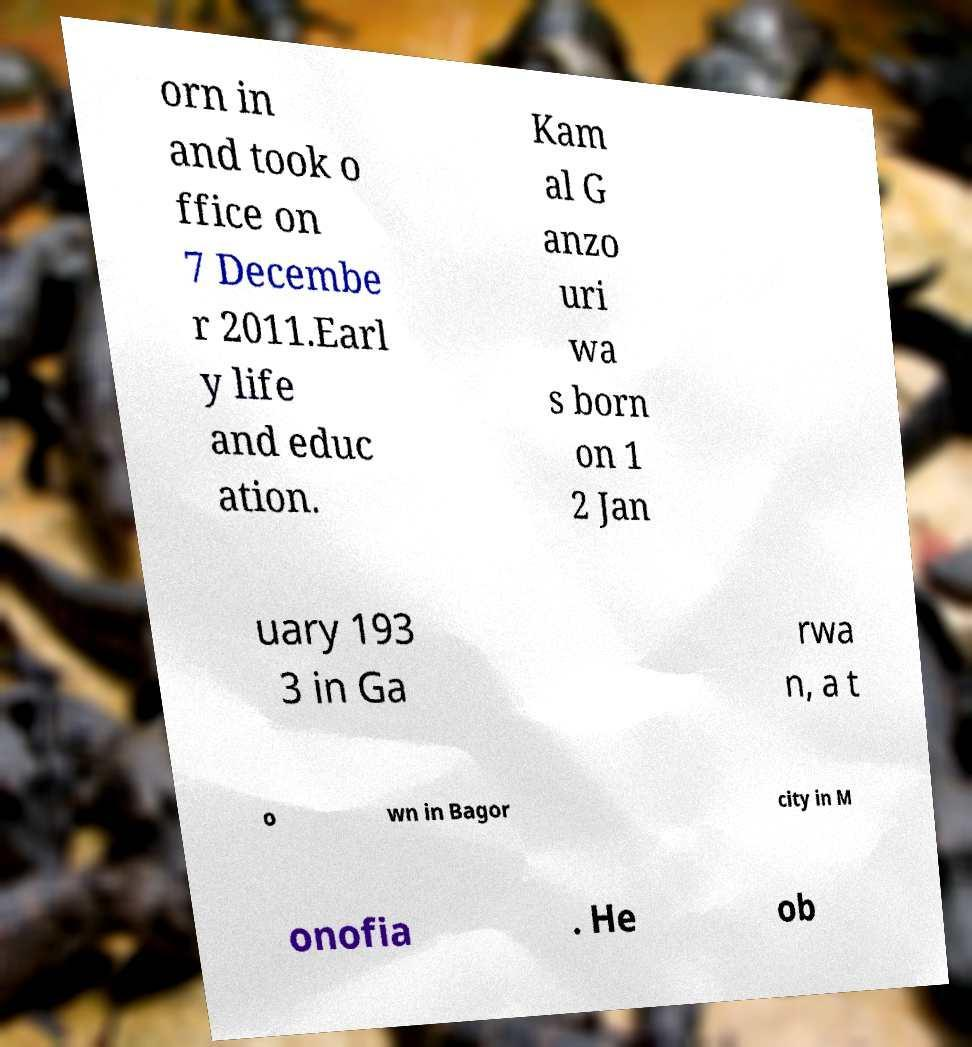For documentation purposes, I need the text within this image transcribed. Could you provide that? orn in and took o ffice on 7 Decembe r 2011.Earl y life and educ ation. Kam al G anzo uri wa s born on 1 2 Jan uary 193 3 in Ga rwa n, a t o wn in Bagor city in M onofia . He ob 